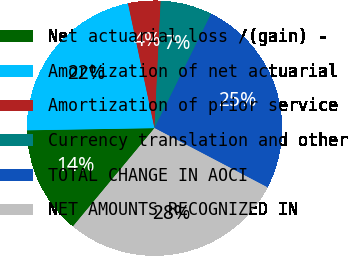<chart> <loc_0><loc_0><loc_500><loc_500><pie_chart><fcel>Net actuarial loss /(gain) -<fcel>Amortization of net actuarial<fcel>Amortization of prior service<fcel>Currency translation and other<fcel>TOTAL CHANGE IN AOCI<fcel>NET AMOUNTS RECOGNIZED IN<nl><fcel>13.71%<fcel>21.94%<fcel>4.11%<fcel>6.54%<fcel>25.37%<fcel>28.34%<nl></chart> 